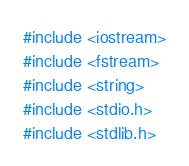Convert code to text. <code><loc_0><loc_0><loc_500><loc_500><_C++_>#include <iostream>
#include <fstream>
#include <string>
#include <stdio.h>
#include <stdlib.h></code> 